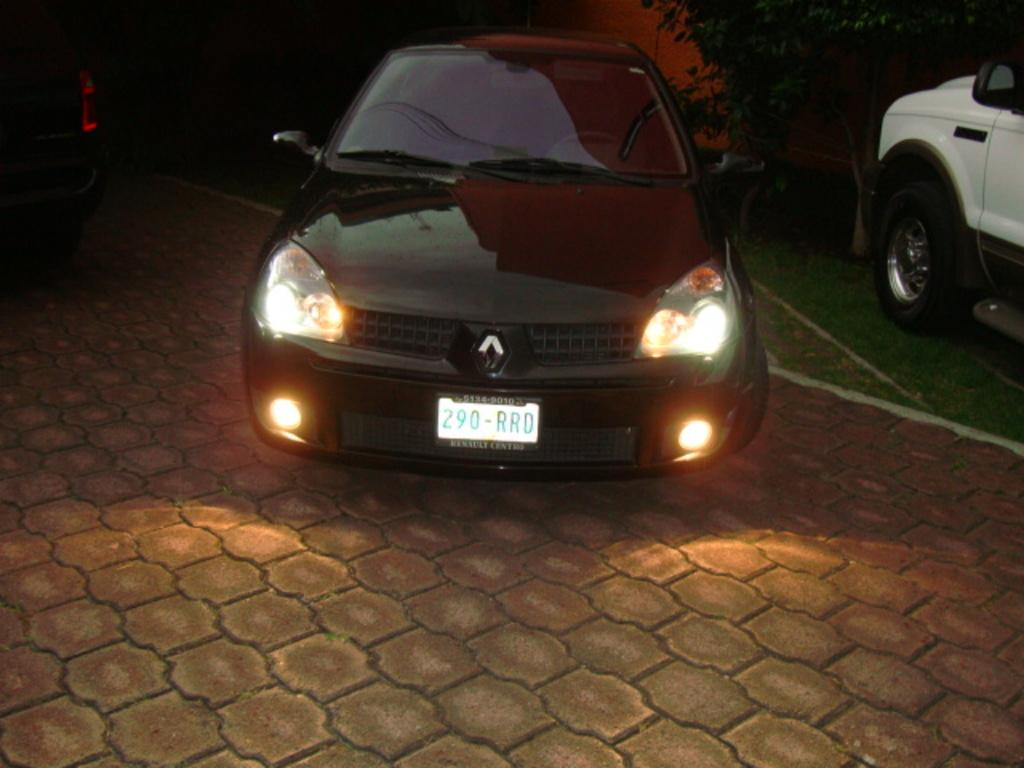What type of vehicles are on the ground in the image? There are cars on the ground in the image. What can be seen in the background of the image? There is a tree in the background of the image. What type of boot is hanging from the tree in the image? There is no boot hanging from the tree in the image; only a tree is visible in the background. 